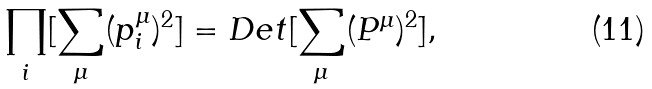Convert formula to latex. <formula><loc_0><loc_0><loc_500><loc_500>\prod _ { i } [ \sum _ { \mu } ( p ^ { \mu } _ { i } ) ^ { 2 } ] = D e t [ \sum _ { \mu } ( P ^ { \mu } ) ^ { 2 } ] ,</formula> 